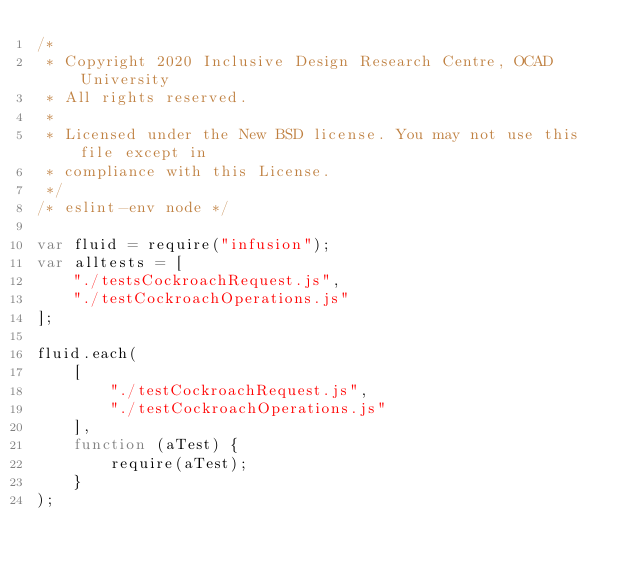<code> <loc_0><loc_0><loc_500><loc_500><_JavaScript_>/*
 * Copyright 2020 Inclusive Design Research Centre, OCAD University
 * All rights reserved.
 *
 * Licensed under the New BSD license. You may not use this file except in
 * compliance with this License.
 */
/* eslint-env node */

var fluid = require("infusion");
var alltests = [
    "./testsCockroachRequest.js",
    "./testCockroachOperations.js"
];

fluid.each(
    [
        "./testCockroachRequest.js", 
        "./testCockroachOperations.js"
    ],
    function (aTest) {
        require(aTest);
    }
);
</code> 